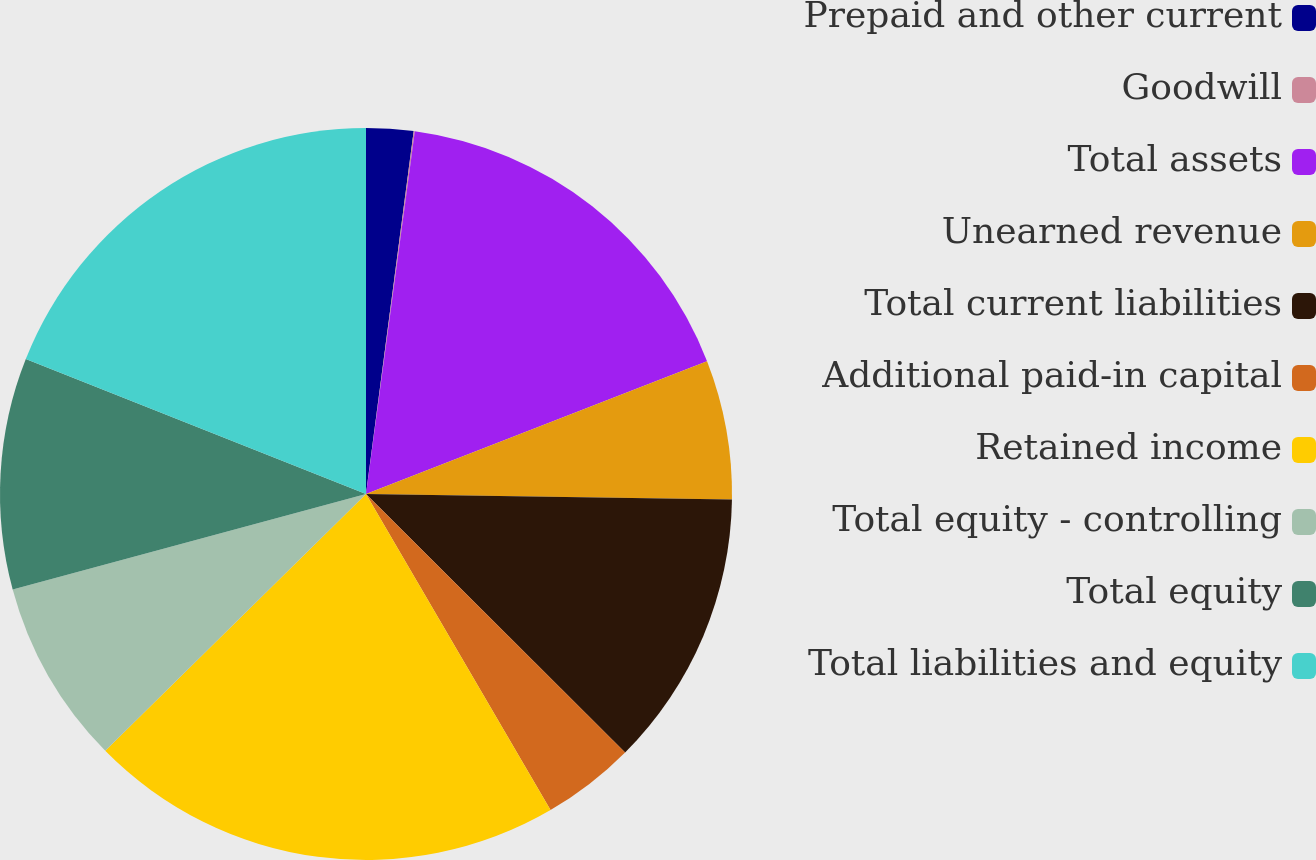Convert chart. <chart><loc_0><loc_0><loc_500><loc_500><pie_chart><fcel>Prepaid and other current<fcel>Goodwill<fcel>Total assets<fcel>Unearned revenue<fcel>Total current liabilities<fcel>Additional paid-in capital<fcel>Retained income<fcel>Total equity - controlling<fcel>Total equity<fcel>Total liabilities and equity<nl><fcel>2.08%<fcel>0.05%<fcel>16.96%<fcel>6.15%<fcel>12.24%<fcel>4.11%<fcel>21.03%<fcel>8.18%<fcel>10.21%<fcel>18.99%<nl></chart> 